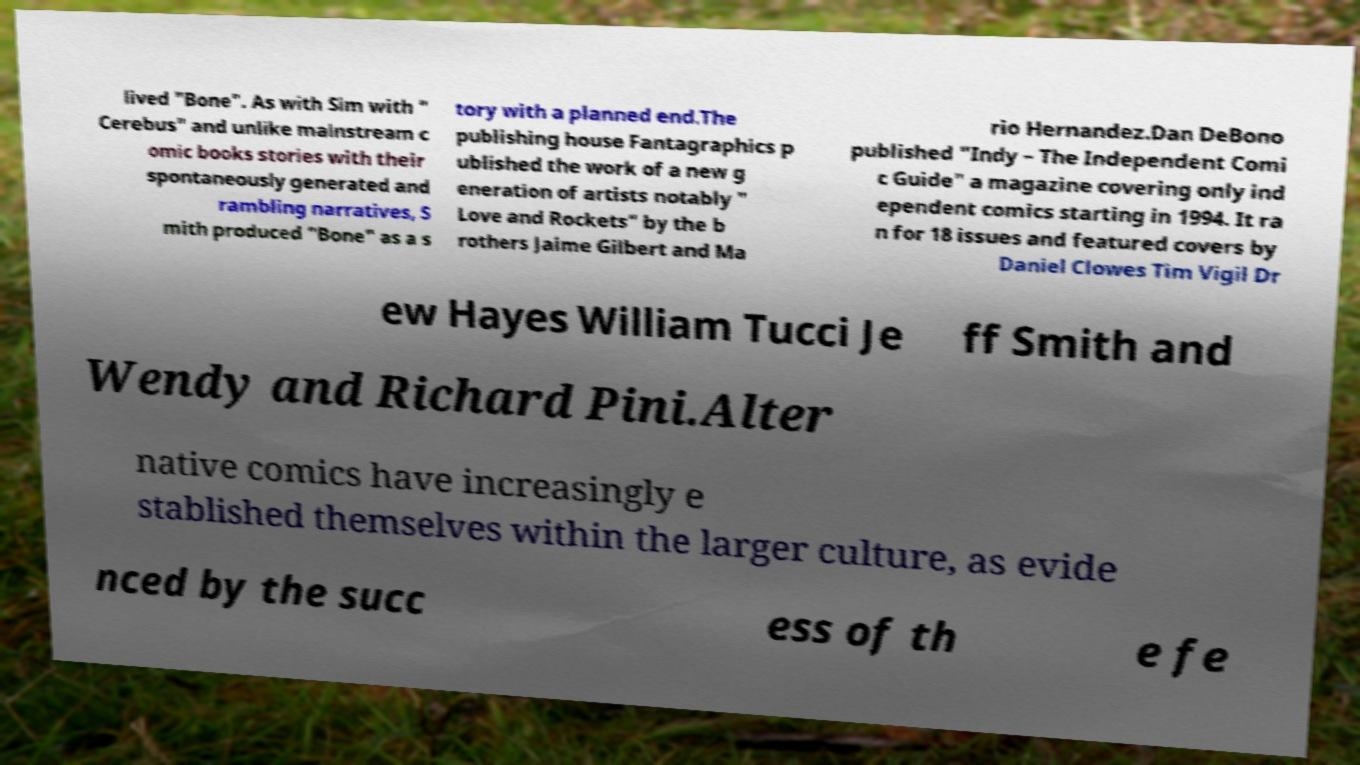I need the written content from this picture converted into text. Can you do that? lived "Bone". As with Sim with " Cerebus" and unlike mainstream c omic books stories with their spontaneously generated and rambling narratives, S mith produced "Bone" as a s tory with a planned end.The publishing house Fantagraphics p ublished the work of a new g eneration of artists notably " Love and Rockets" by the b rothers Jaime Gilbert and Ma rio Hernandez.Dan DeBono published "Indy – The Independent Comi c Guide" a magazine covering only ind ependent comics starting in 1994. It ra n for 18 issues and featured covers by Daniel Clowes Tim Vigil Dr ew Hayes William Tucci Je ff Smith and Wendy and Richard Pini.Alter native comics have increasingly e stablished themselves within the larger culture, as evide nced by the succ ess of th e fe 